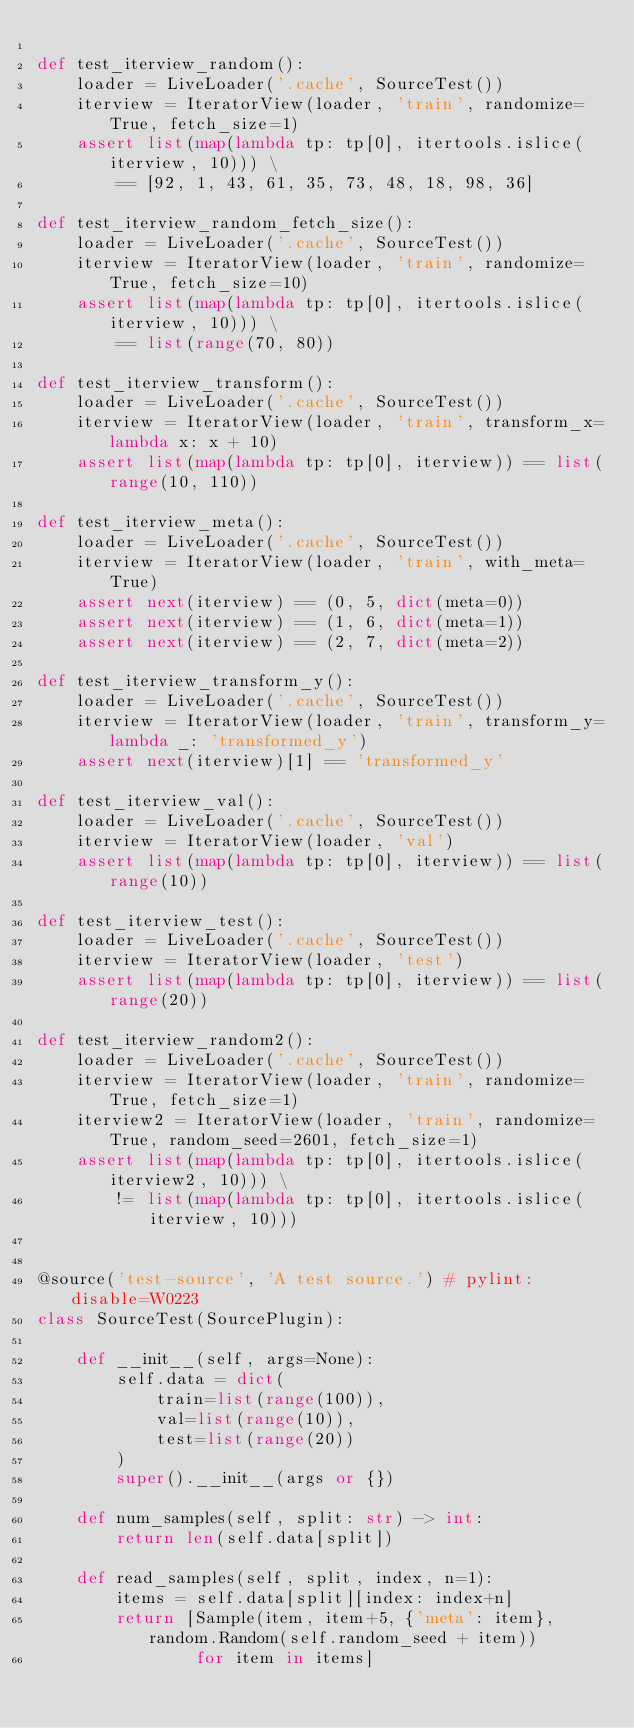<code> <loc_0><loc_0><loc_500><loc_500><_Python_>
def test_iterview_random():
    loader = LiveLoader('.cache', SourceTest())
    iterview = IteratorView(loader, 'train', randomize=True, fetch_size=1)
    assert list(map(lambda tp: tp[0], itertools.islice(iterview, 10))) \
        == [92, 1, 43, 61, 35, 73, 48, 18, 98, 36]

def test_iterview_random_fetch_size():
    loader = LiveLoader('.cache', SourceTest())
    iterview = IteratorView(loader, 'train', randomize=True, fetch_size=10)
    assert list(map(lambda tp: tp[0], itertools.islice(iterview, 10))) \
        == list(range(70, 80))

def test_iterview_transform():
    loader = LiveLoader('.cache', SourceTest())
    iterview = IteratorView(loader, 'train', transform_x=lambda x: x + 10)
    assert list(map(lambda tp: tp[0], iterview)) == list(range(10, 110))

def test_iterview_meta():
    loader = LiveLoader('.cache', SourceTest())
    iterview = IteratorView(loader, 'train', with_meta=True)
    assert next(iterview) == (0, 5, dict(meta=0))
    assert next(iterview) == (1, 6, dict(meta=1))
    assert next(iterview) == (2, 7, dict(meta=2))

def test_iterview_transform_y():
    loader = LiveLoader('.cache', SourceTest())
    iterview = IteratorView(loader, 'train', transform_y=lambda _: 'transformed_y')
    assert next(iterview)[1] == 'transformed_y'

def test_iterview_val():
    loader = LiveLoader('.cache', SourceTest())
    iterview = IteratorView(loader, 'val')
    assert list(map(lambda tp: tp[0], iterview)) == list(range(10))

def test_iterview_test():
    loader = LiveLoader('.cache', SourceTest())
    iterview = IteratorView(loader, 'test')
    assert list(map(lambda tp: tp[0], iterview)) == list(range(20))

def test_iterview_random2():
    loader = LiveLoader('.cache', SourceTest())
    iterview = IteratorView(loader, 'train', randomize=True, fetch_size=1)
    iterview2 = IteratorView(loader, 'train', randomize=True, random_seed=2601, fetch_size=1)
    assert list(map(lambda tp: tp[0], itertools.islice(iterview2, 10))) \
        != list(map(lambda tp: tp[0], itertools.islice(iterview, 10)))


@source('test-source', 'A test source.') # pylint: disable=W0223
class SourceTest(SourcePlugin):

    def __init__(self, args=None):
        self.data = dict(
            train=list(range(100)),
            val=list(range(10)),
            test=list(range(20))
        )
        super().__init__(args or {})

    def num_samples(self, split: str) -> int:
        return len(self.data[split])

    def read_samples(self, split, index, n=1):
        items = self.data[split][index: index+n]
        return [Sample(item, item+5, {'meta': item}, random.Random(self.random_seed + item))
                for item in items]
</code> 